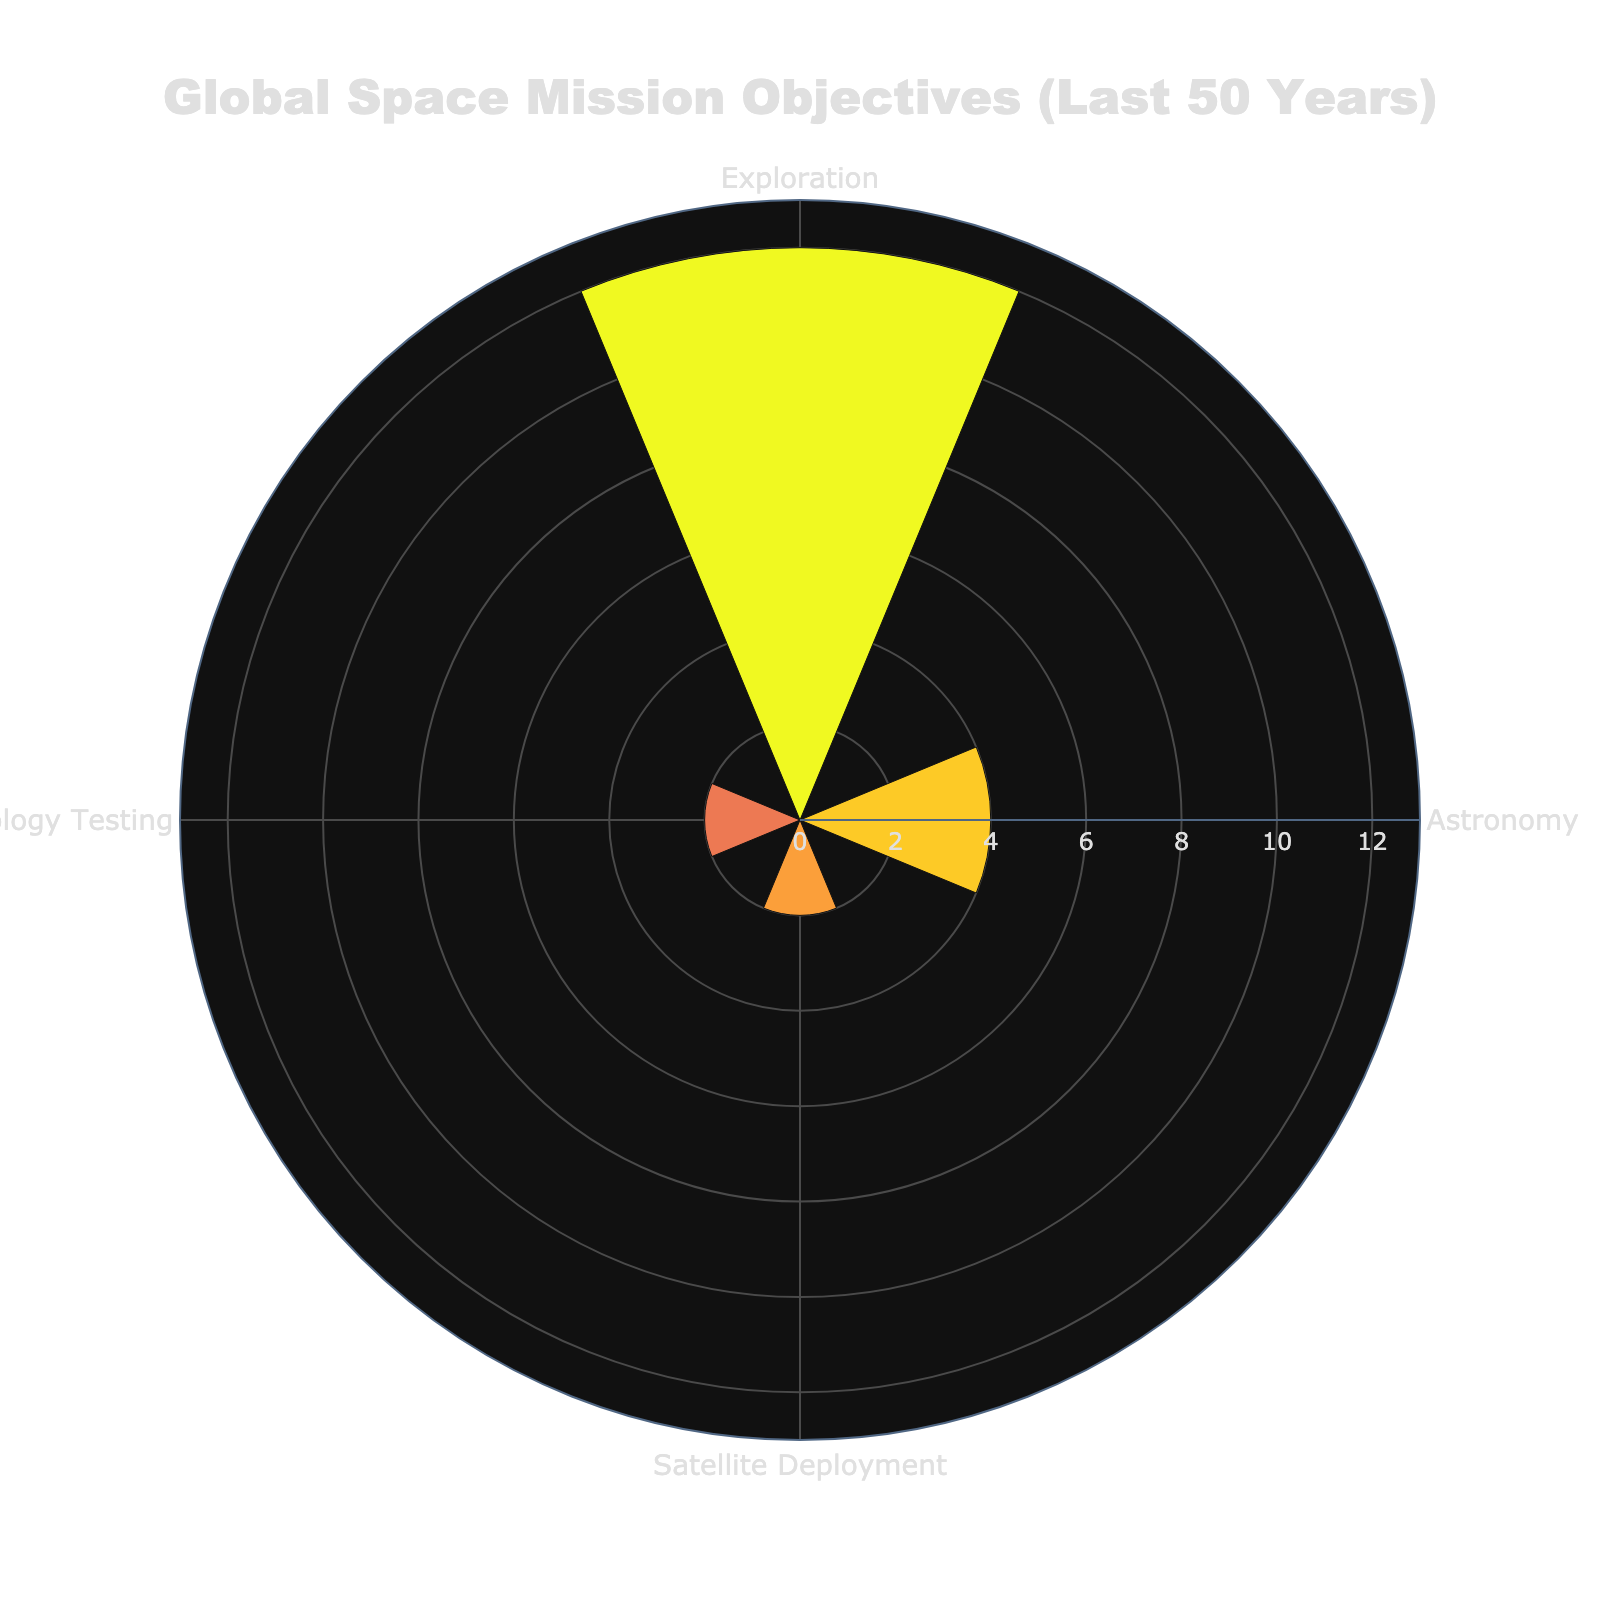How many space missions focused on technology testing in the last 50 years? Look at the radial axis labeled "Technology Testing" on the rose chart and count the missions corresponding to this objective.
Answer: 2 Which objective category has the highest number of missions? Compare the radial measurements (distances from the center) of all the objective categories on the rose chart. The category with the largest radial distance has the highest number of missions.
Answer: Exploration How many more exploration missions were there compared to astronomy missions? Count the missions for both Exploration and Astronomy by looking at their respective radial axis values. Subtract the number of Astronomy missions from Exploration missions to find the difference.
Answer: 9 What is the least common objective in global space missions? Identify which objective category has the shortest radial axis distance in the rose chart, indicating the fewest number of missions.
Answer: Technology Testing In which year were the most missions launched for exploration? Check the provided data and identify the year with the highest number of exploration missions. Refer back to the data rather than the rose chart for specifics on years.
Answer: 2018 How many missions were launched for astronomy before the year 2000? Review the given data for all missions categorized under Astronomy and tally the ones launched before the year 2000.
Answer: 1 What is the total number of missions represented in the rose chart? Sum the counts from all objective categories presented in the rose chart.
Answer: 19 Which objective had exactly three distinct years with missions launched? Look at the provided data to see how many distinct launching years each objective category has. Identify the objective that aligns with having exactly three distinct years.
Answer: Satellite Deployment Are there more missions aimed at satellite deployment or technology testing? Compare the number of missions under Satellite Deployment to those under Technology Testing using the radial axis values for these categories in the rose chart.
Answer: Satellite Deployment What is the count difference between the two middle-ranked objective categories? Identify and order the mission counts for each category. Determine the middle two categories and calculate the difference between their counts.
Answer: 2 